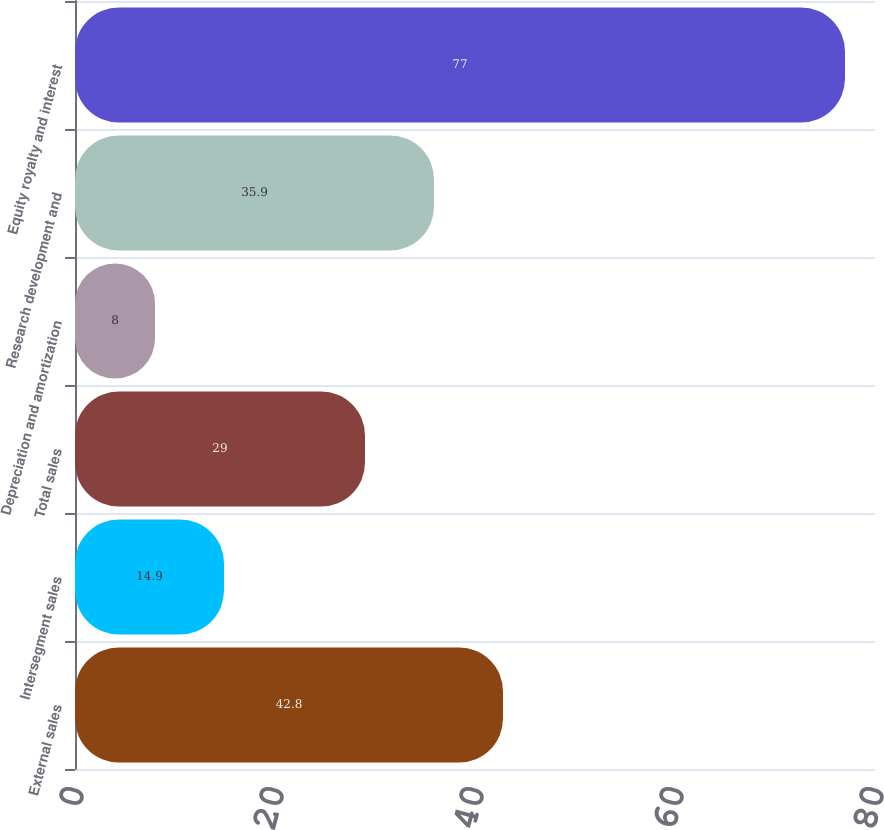<chart> <loc_0><loc_0><loc_500><loc_500><bar_chart><fcel>External sales<fcel>Intersegment sales<fcel>Total sales<fcel>Depreciation and amortization<fcel>Research development and<fcel>Equity royalty and interest<nl><fcel>42.8<fcel>14.9<fcel>29<fcel>8<fcel>35.9<fcel>77<nl></chart> 